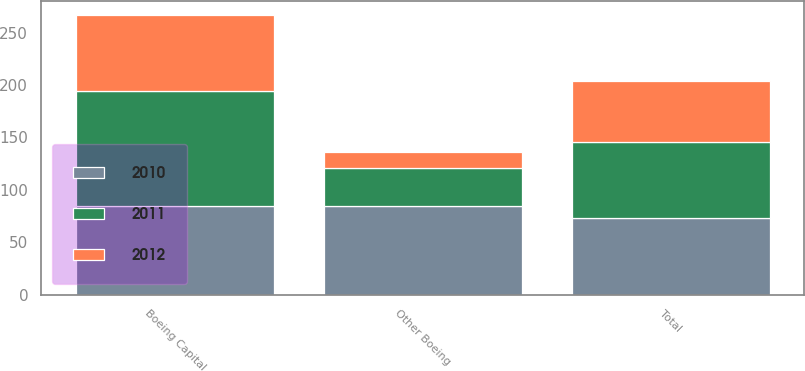Convert chart to OTSL. <chart><loc_0><loc_0><loc_500><loc_500><stacked_bar_chart><ecel><fcel>Boeing Capital<fcel>Other Boeing<fcel>Total<nl><fcel>2012<fcel>73<fcel>15<fcel>58<nl><fcel>2011<fcel>109<fcel>36<fcel>73<nl><fcel>2010<fcel>85<fcel>85<fcel>73<nl></chart> 